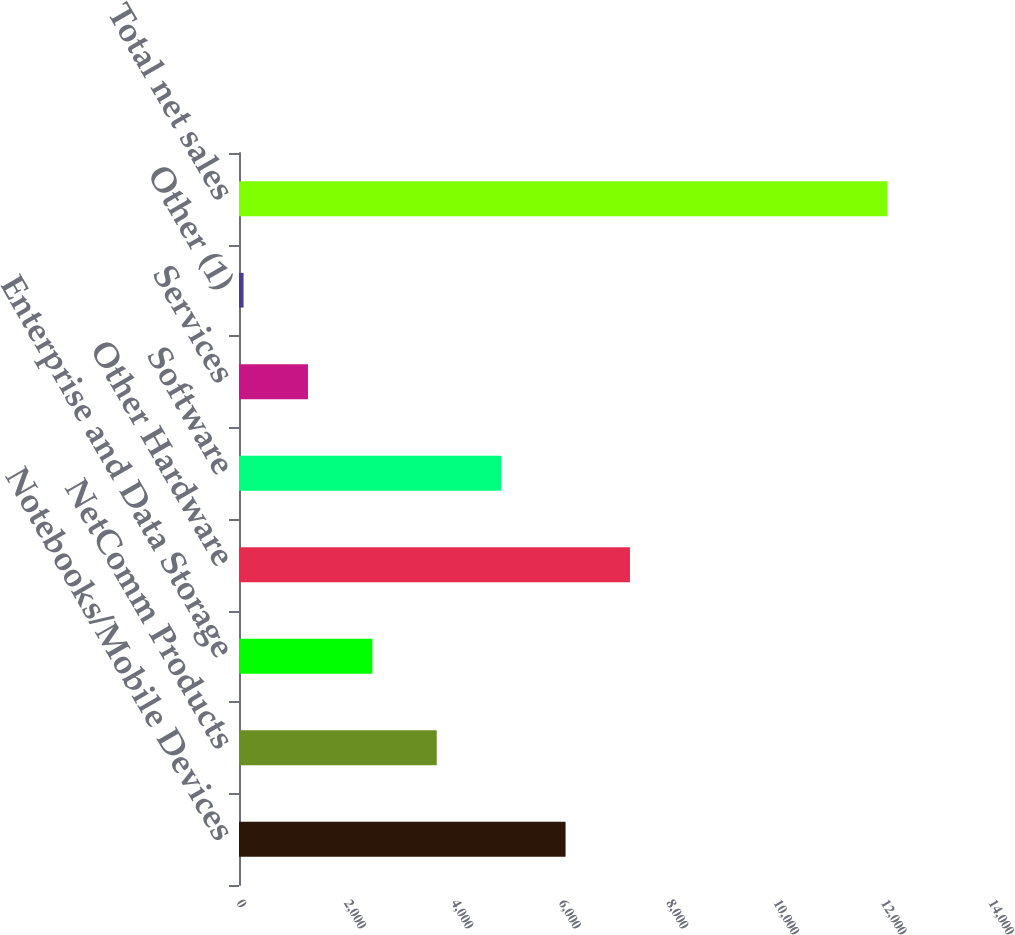Convert chart. <chart><loc_0><loc_0><loc_500><loc_500><bar_chart><fcel>Notebooks/Mobile Devices<fcel>NetComm Products<fcel>Enterprise and Data Storage<fcel>Other Hardware<fcel>Software<fcel>Services<fcel>Other (1)<fcel>Total net sales<nl><fcel>6079.6<fcel>3681.64<fcel>2482.66<fcel>7278.58<fcel>4880.62<fcel>1283.68<fcel>84.7<fcel>12074.5<nl></chart> 